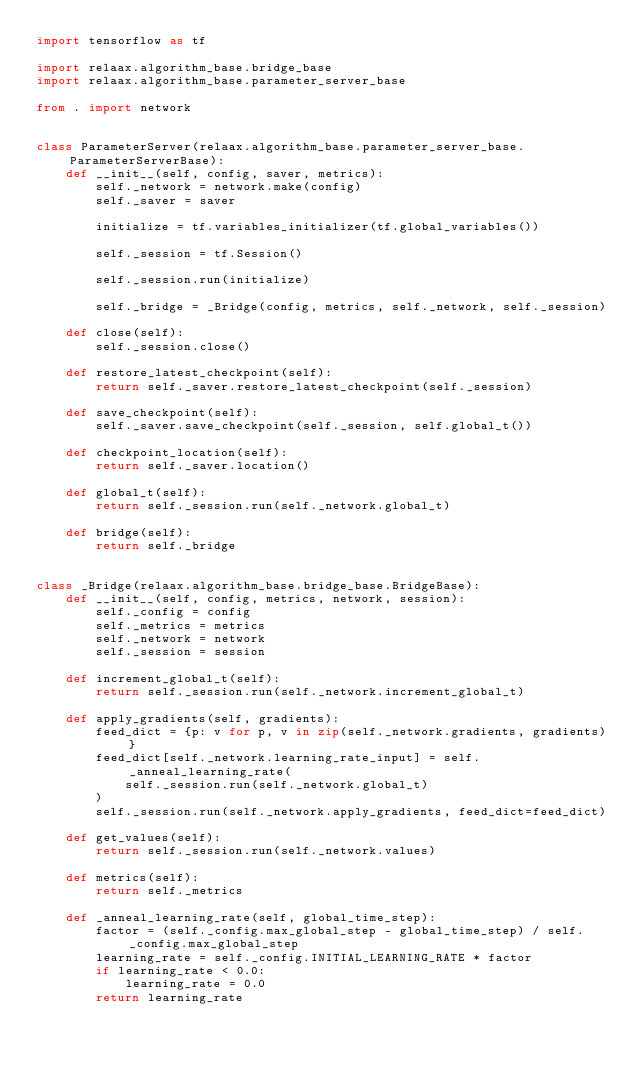Convert code to text. <code><loc_0><loc_0><loc_500><loc_500><_Python_>import tensorflow as tf

import relaax.algorithm_base.bridge_base
import relaax.algorithm_base.parameter_server_base

from . import network


class ParameterServer(relaax.algorithm_base.parameter_server_base.ParameterServerBase):
    def __init__(self, config, saver, metrics):
        self._network = network.make(config)
        self._saver = saver

        initialize = tf.variables_initializer(tf.global_variables())

        self._session = tf.Session()

        self._session.run(initialize)

        self._bridge = _Bridge(config, metrics, self._network, self._session)

    def close(self):
        self._session.close()

    def restore_latest_checkpoint(self):
        return self._saver.restore_latest_checkpoint(self._session)

    def save_checkpoint(self):
        self._saver.save_checkpoint(self._session, self.global_t())

    def checkpoint_location(self):
        return self._saver.location()

    def global_t(self):
        return self._session.run(self._network.global_t)

    def bridge(self):
        return self._bridge


class _Bridge(relaax.algorithm_base.bridge_base.BridgeBase):
    def __init__(self, config, metrics, network, session):
        self._config = config
        self._metrics = metrics
        self._network = network
        self._session = session

    def increment_global_t(self):
        return self._session.run(self._network.increment_global_t)

    def apply_gradients(self, gradients):
        feed_dict = {p: v for p, v in zip(self._network.gradients, gradients)}
        feed_dict[self._network.learning_rate_input] = self._anneal_learning_rate(
            self._session.run(self._network.global_t)
        )
        self._session.run(self._network.apply_gradients, feed_dict=feed_dict)

    def get_values(self):
        return self._session.run(self._network.values)

    def metrics(self):
        return self._metrics

    def _anneal_learning_rate(self, global_time_step):
        factor = (self._config.max_global_step - global_time_step) / self._config.max_global_step
        learning_rate = self._config.INITIAL_LEARNING_RATE * factor
        if learning_rate < 0.0:
            learning_rate = 0.0
        return learning_rate
</code> 